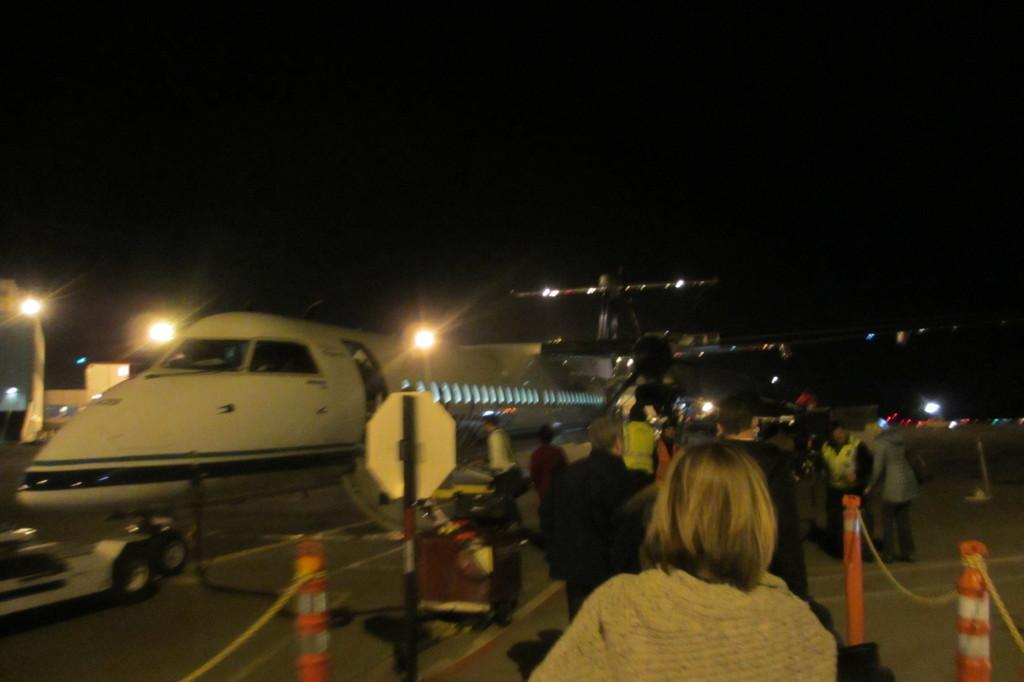What is the main subject of the image? The main subject of the image is an aeroplane. What other objects can be seen in the image? There are poles, ropes, people, and lights visible in the image. What is the condition of the background in the image? The background of the image has a dark view. What type of fowl can be seen wearing a stocking in the image? There is no fowl or stocking present in the image. Can you tell me how many receipts are visible in the image? There are no receipts present in the image. 